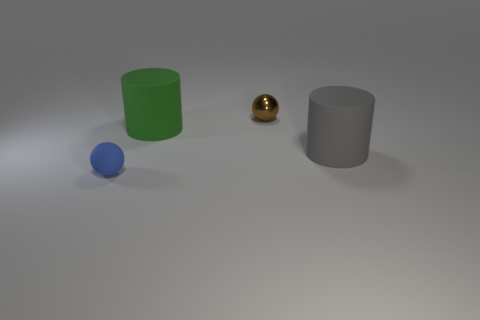The ball that is the same material as the big green cylinder is what color?
Give a very brief answer. Blue. Is the tiny rubber thing the same shape as the big gray thing?
Ensure brevity in your answer.  No. There is a tiny sphere that is in front of the small object to the right of the small blue thing; are there any gray rubber things in front of it?
Provide a short and direct response. No. What number of other shiny balls are the same color as the tiny metallic ball?
Make the answer very short. 0. What shape is the rubber object that is the same size as the brown sphere?
Keep it short and to the point. Sphere. There is a large gray cylinder; are there any metallic spheres to the left of it?
Ensure brevity in your answer.  Yes. Do the gray cylinder and the green thing have the same size?
Your response must be concise. Yes. What is the shape of the large matte thing behind the big gray rubber object?
Offer a terse response. Cylinder. Are there any other metal things of the same size as the brown metallic thing?
Your response must be concise. No. There is another sphere that is the same size as the brown metallic sphere; what is it made of?
Offer a terse response. Rubber. 